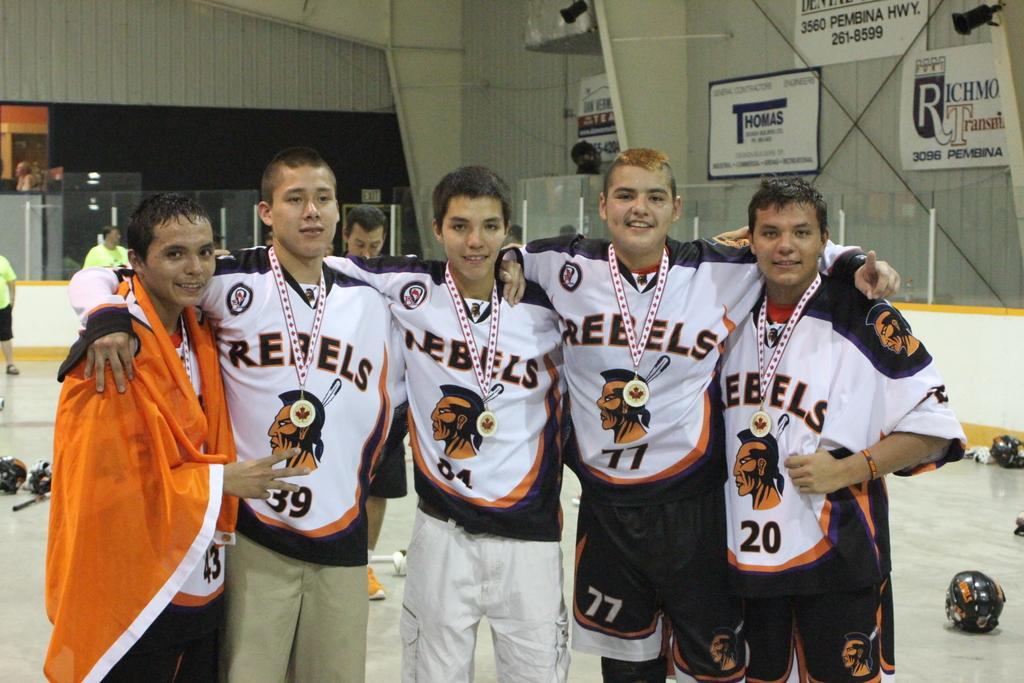<image>
Present a compact description of the photo's key features. A bunch of sports players, most of whom are wearing shirts with the word Rebels on. 